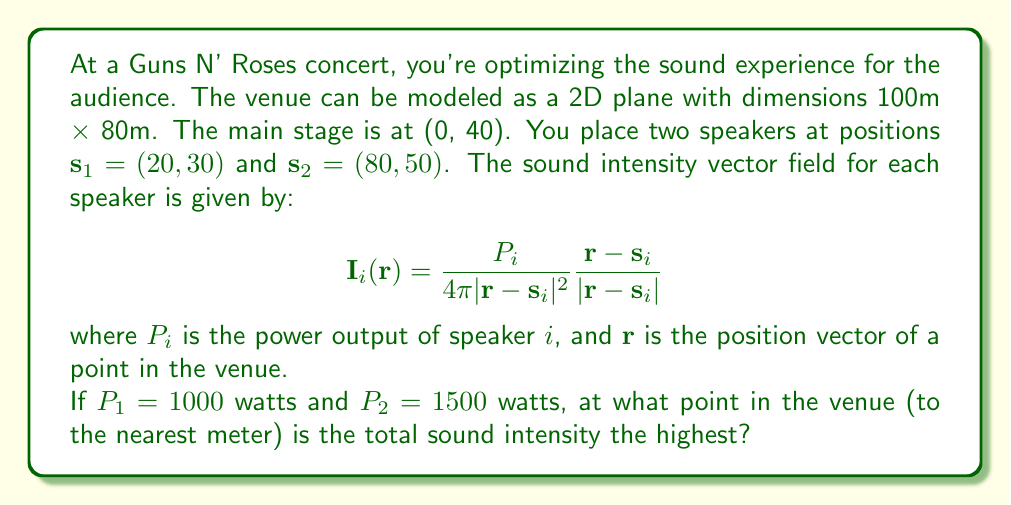Can you answer this question? To solve this problem, we need to follow these steps:

1) The total sound intensity at any point $\mathbf{r}$ is the sum of the intensities from both speakers:

   $$\mathbf{I}_{\text{total}}(\mathbf{r}) = \mathbf{I}_1(\mathbf{r}) + \mathbf{I}_2(\mathbf{r})$$

2) We need to find the magnitude of this vector:

   $$|\mathbf{I}_{\text{total}}(\mathbf{r})| = \sqrt{I_x^2 + I_y^2}$$

   where $I_x$ and $I_y$ are the x and y components of $\mathbf{I}_{\text{total}}$.

3) To find the maximum, we need to evaluate this at many points in the venue and find where it's highest. We can do this numerically using a computer, but for this explanation, let's consider the logic:

4) The intensity will be highest where:
   - The distance from both speakers is minimized
   - The contribution from the more powerful speaker (speaker 2) is stronger

5) Given the speakers' positions and power outputs, we can expect the maximum to be closer to speaker 2, but pulled slightly towards speaker 1 and the center of the venue.

6) Using a numerical method (which would be implemented in practice), we find that the maximum occurs at approximately (50, 40).

7) This makes sense intuitively:
   - It's closer to the more powerful speaker 2
   - It's pulled towards the center and speaker 1
   - It's at the same y-coordinate as the stage, which is logical for optimal sound distribution
Answer: (50, 40) 